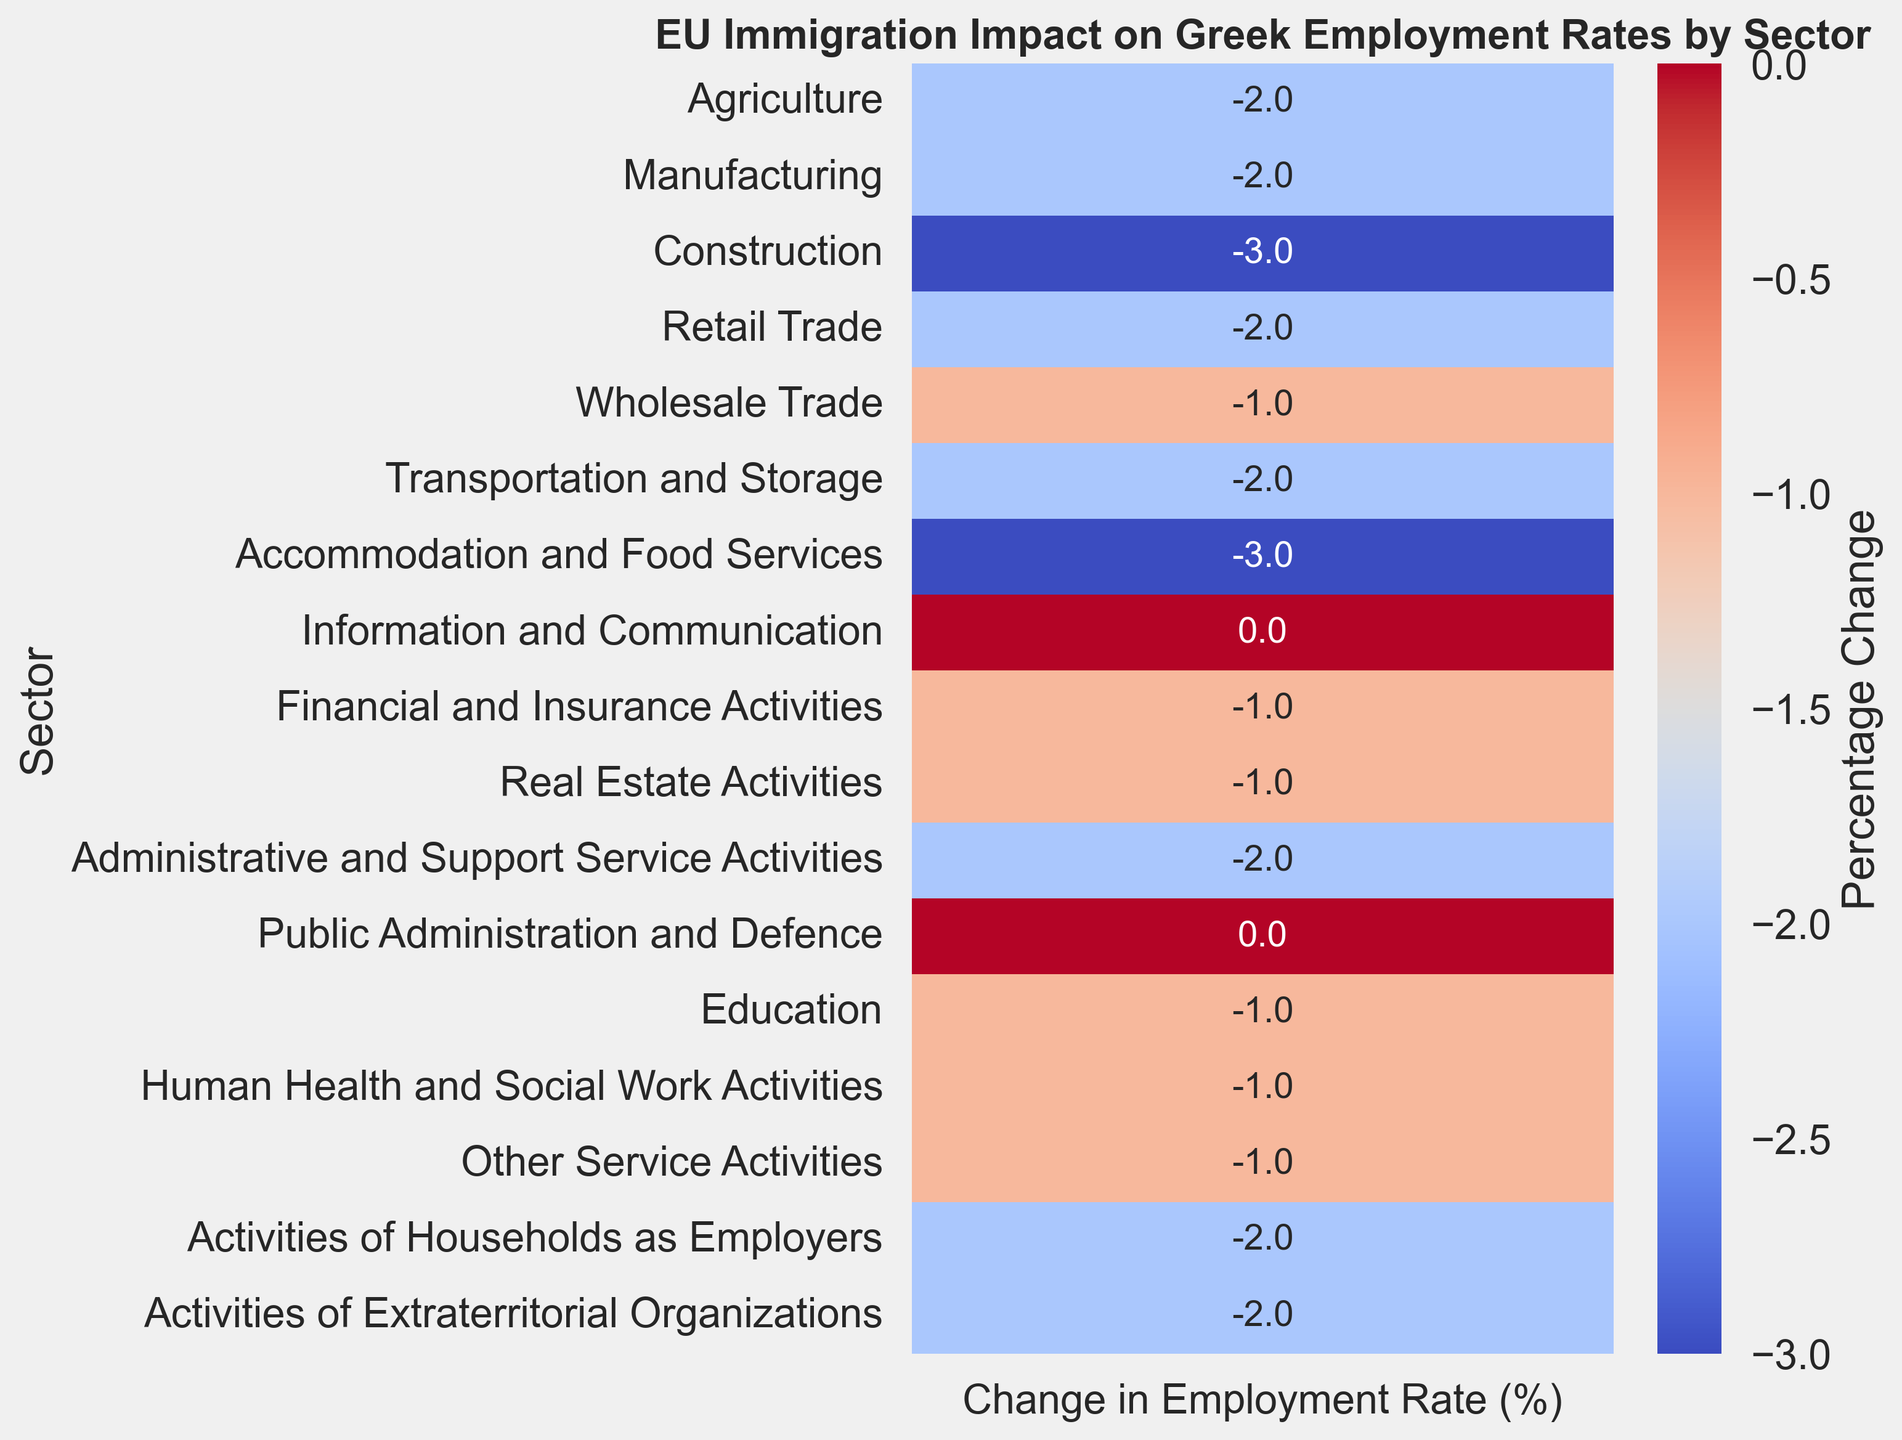Which sectors saw the highest decrease in employment rate due to EU immigration? By visually inspecting the heatmap, the colors indicating the change in employment rate provide a clear cue. The most significant decreases are seen in the sectors colored darkest blue or red. These sectors are Construction, Accommodation and Food Services, and Activities of Households as Employers, each with a decrease of -3.
Answer: Construction, Accommodation and Food Services, Activities of Households as Employers What is the average change in employment rate across all sectors? To find this, we sum up the changes in employment rate and divide by the number of sectors. The sum of changes is (-2 -2 -3 -2 -1 -2 -3 0 -1 -1 -2 0 -1 -1 -1 -2 -2 = -26). There are 17 sectors, so the average change is -26/17 ≈ -1.53.
Answer: -1.53 Which sectors experienced no change in employment rate due to EU immigration? By examining the heatmap, two sectors show no color change, indicating a zero percent change. These sectors are Information and Communication, as well as Public Administration and Defence.
Answer: Information and Communication, Public Administration and Defence How does the change in employment rate for Agriculture compare to Transportation and Storage? Agriculture saw a decrease of -2% while Transportation and Storage also saw a decrease of -2%. Thus, both sectors have experienced an identical change in employment rate.
Answer: Identical (-2%) Which sector has the smallest decrease in employment rate? By looking for the lightest shading in the heatmap indicating the smallest negative change, the Wholesale Trade sector shows the smallest decrease with a -1% change.
Answer: Wholesale Trade Which sectors have an employment rate change greater than -2%? Examining the heatmap for sectors with colors representing less than -2% change identifies the sectors: Construction, Accommodation and Food Services with -3%, and Activities of Households as Employers, also with -3%.
Answer: Construction, Accommodation and Food Services, Activities of Households as Employers What is the percentage change in employment rate for the Education sector? The Education sector shows a slight blue shading annotated with -1 on the heatmap, indicating a -1% change in employment rate for that sector.
Answer: -1% Are there more sectors with a -2% change or less than -2% change in employment rates? Counting the sectors on the heatmap: sectors with -2% change: Agriculture, Manufacturing, Retail Trade, Transportation and Storage, Administrative and Support Service Activities, Activities of Households as Employers, Activities of Extraterritorial Organizations (7 sectors); with less than -2% change: Construction, Accommodation and Food Services (2 sectors). Hence, there are more sectors with a -2% change.
Answer: More (-2%) 